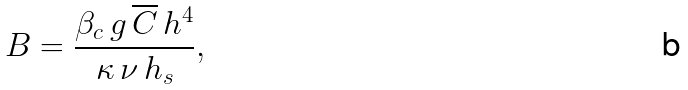Convert formula to latex. <formula><loc_0><loc_0><loc_500><loc_500>B = \frac { \beta _ { c } \, g \, \overline { C } \, h ^ { 4 } } { \kappa \, \nu \, h _ { s } } ,</formula> 